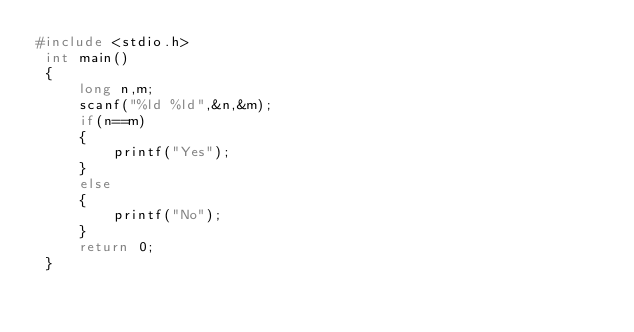<code> <loc_0><loc_0><loc_500><loc_500><_C_>#include <stdio.h>
 int main()
 {
     long n,m;
     scanf("%ld %ld",&n,&m);
     if(n==m)
     {
         printf("Yes");
     }
     else 
     {
         printf("No");
     }
     return 0;
 }</code> 